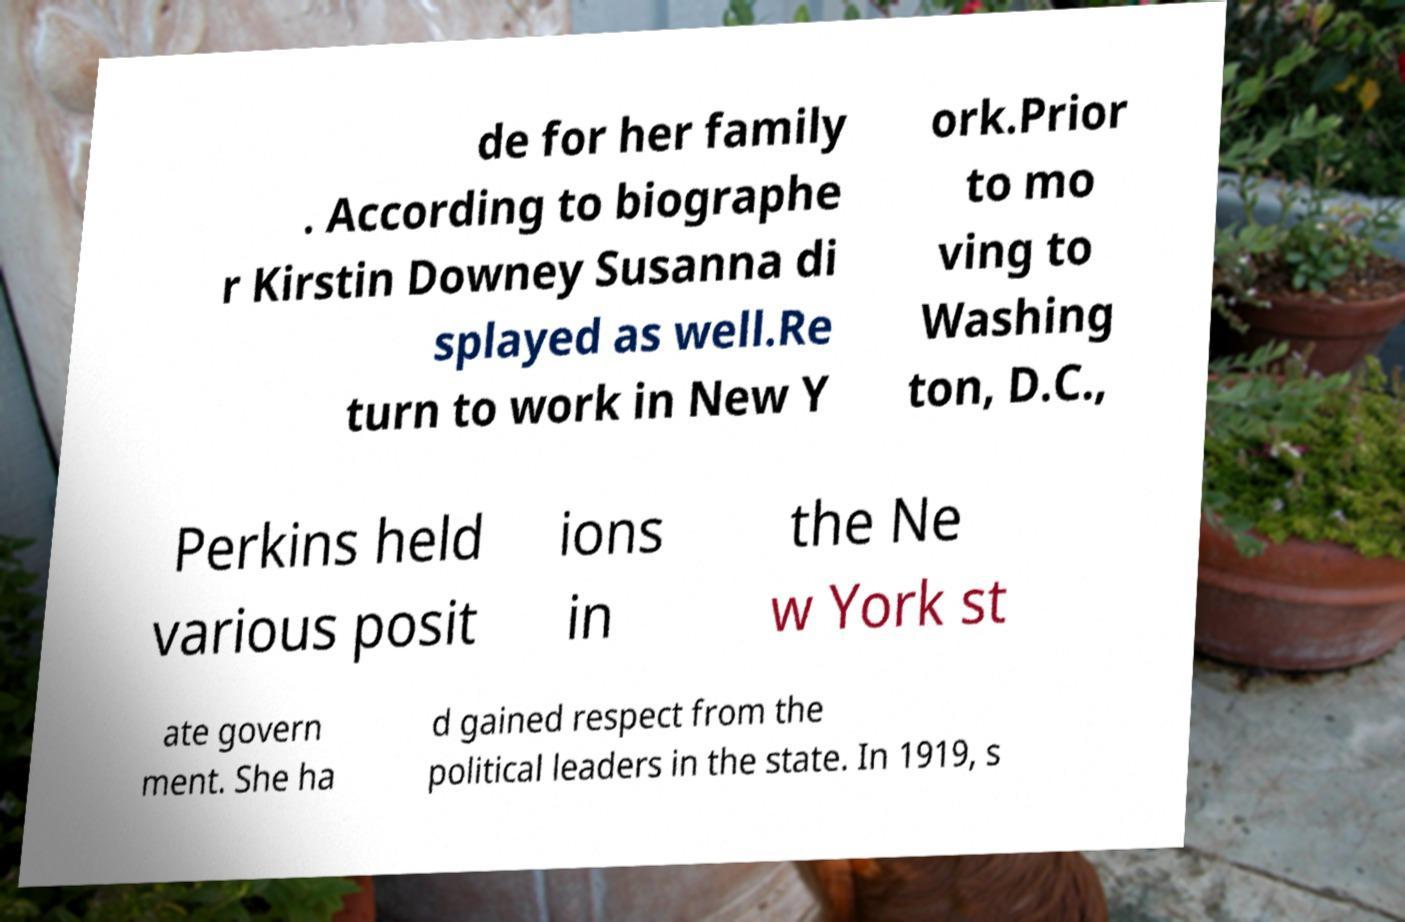For documentation purposes, I need the text within this image transcribed. Could you provide that? de for her family . According to biographe r Kirstin Downey Susanna di splayed as well.Re turn to work in New Y ork.Prior to mo ving to Washing ton, D.C., Perkins held various posit ions in the Ne w York st ate govern ment. She ha d gained respect from the political leaders in the state. In 1919, s 